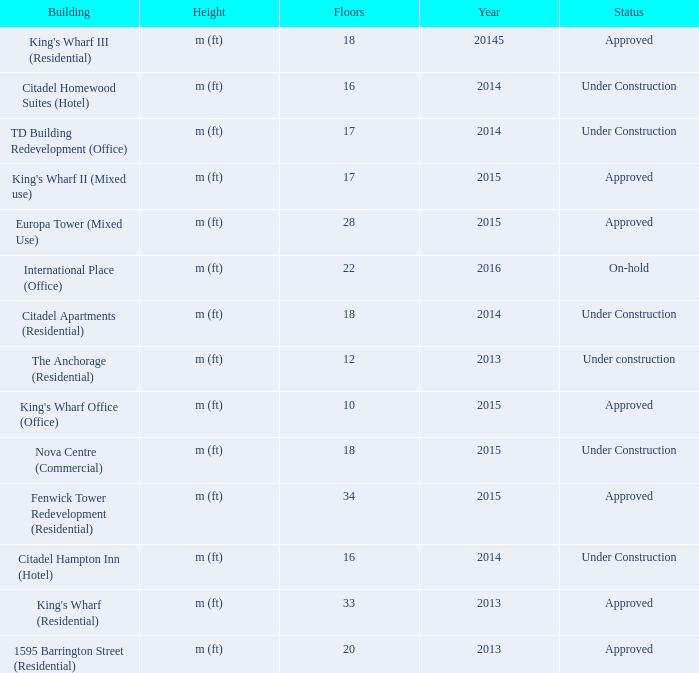What is the status of the building with more than 28 floor and a year of 2013? Approved. 